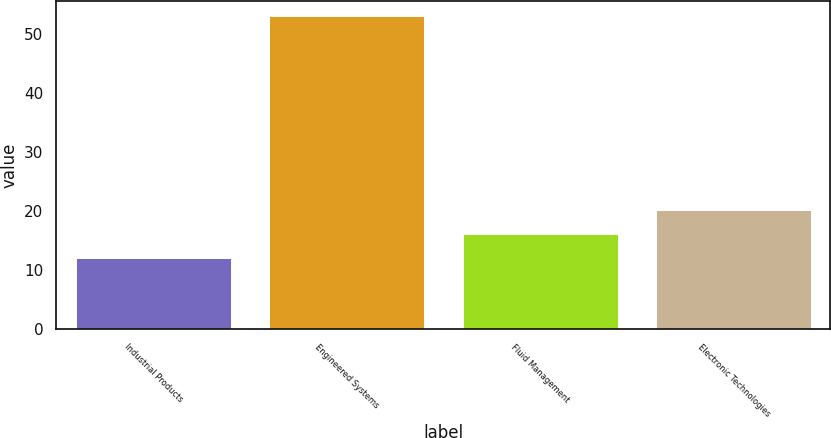<chart> <loc_0><loc_0><loc_500><loc_500><bar_chart><fcel>Industrial Products<fcel>Engineered Systems<fcel>Fluid Management<fcel>Electronic Technologies<nl><fcel>12<fcel>53<fcel>16.1<fcel>20.2<nl></chart> 